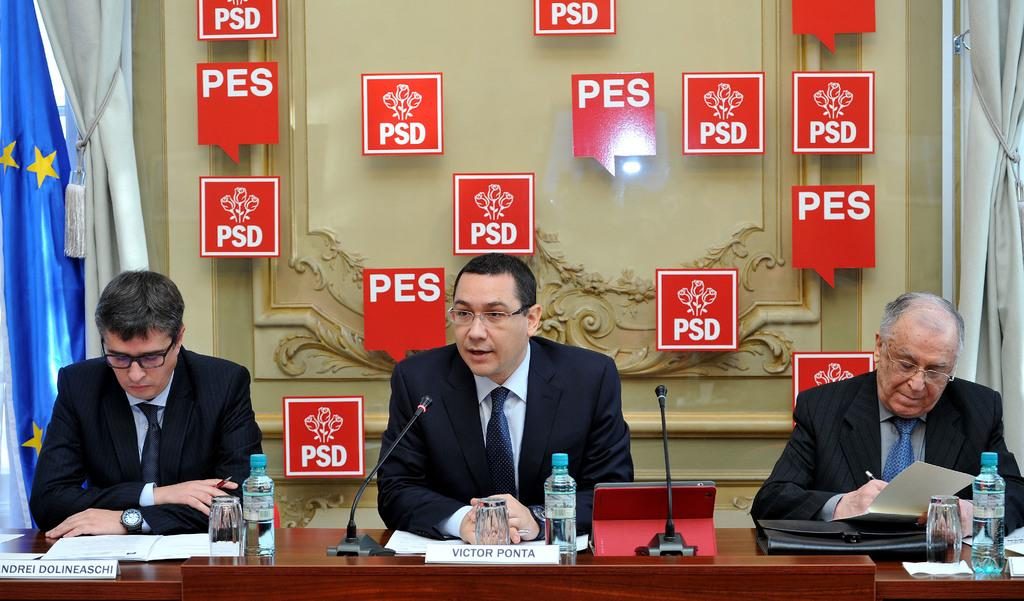<image>
Describe the image concisely. Three men giving a speech behind and a man behind a sign saying Victor Ponta speaking. 